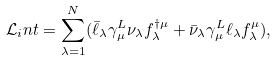<formula> <loc_0><loc_0><loc_500><loc_500>\mathcal { L } _ { i } n t = \sum _ { \lambda = 1 } ^ { N } ( \bar { \ell } _ { \lambda } \gamma _ { \mu } ^ { L } \nu _ { \lambda } f _ { \lambda } ^ { \dag \mu } + \bar { \nu } _ { \lambda } \gamma _ { \mu } ^ { L } \ell _ { \lambda } f _ { \lambda } ^ { \mu } ) ,</formula> 